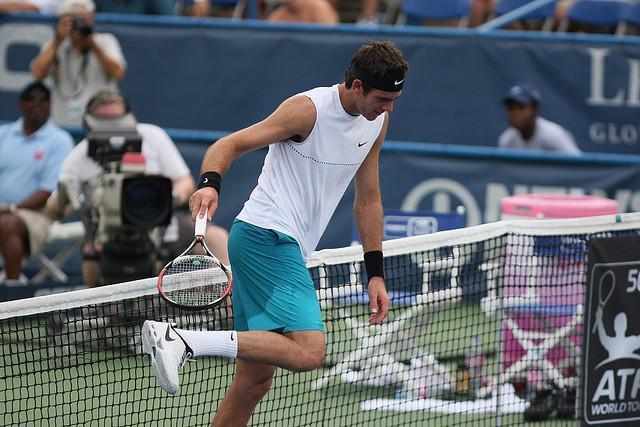How many people are in the photo?
Give a very brief answer. 5. How many chairs are there?
Give a very brief answer. 2. 